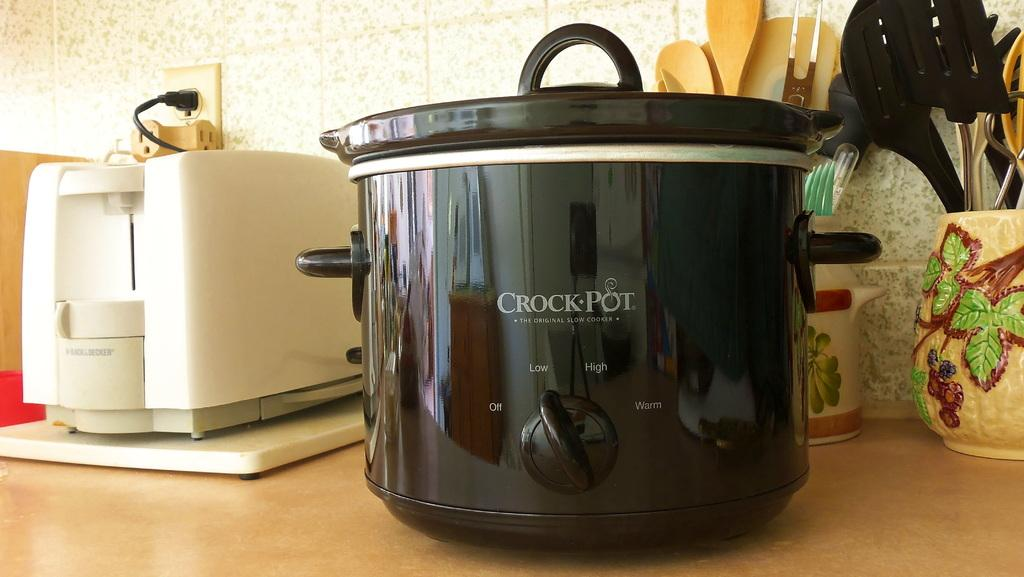<image>
Give a short and clear explanation of the subsequent image. Black Crock Pot with the option to turn it high or low. 